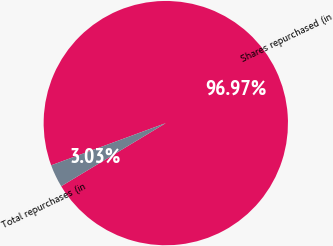Convert chart. <chart><loc_0><loc_0><loc_500><loc_500><pie_chart><fcel>Shares repurchased (in<fcel>Total repurchases (in<nl><fcel>96.97%<fcel>3.03%<nl></chart> 